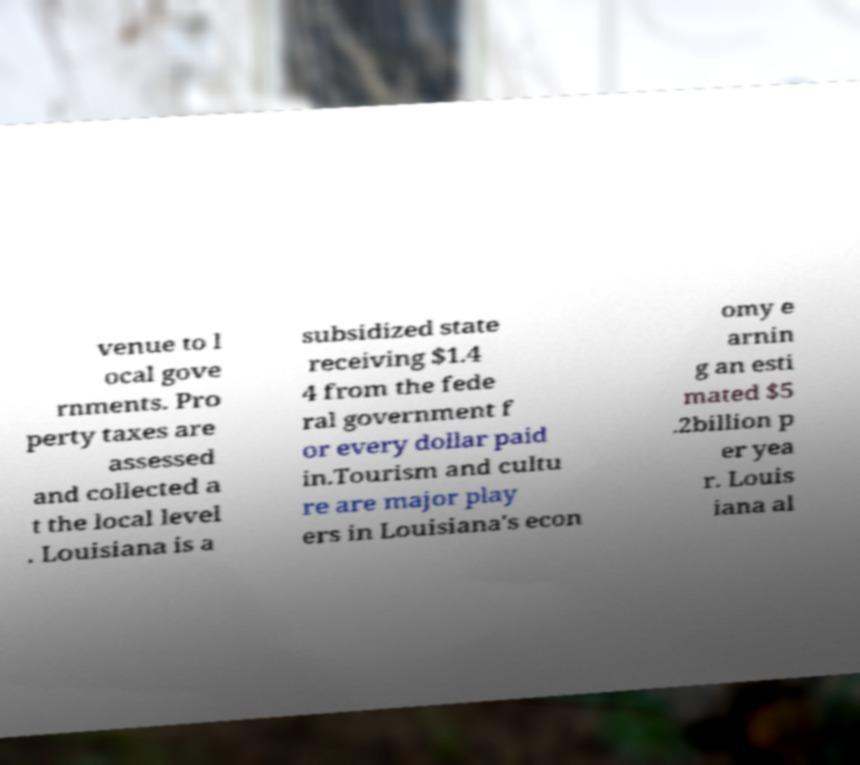Could you assist in decoding the text presented in this image and type it out clearly? venue to l ocal gove rnments. Pro perty taxes are assessed and collected a t the local level . Louisiana is a subsidized state receiving $1.4 4 from the fede ral government f or every dollar paid in.Tourism and cultu re are major play ers in Louisiana's econ omy e arnin g an esti mated $5 .2billion p er yea r. Louis iana al 